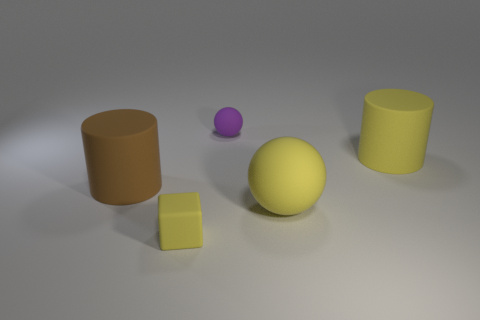Add 4 tiny matte balls. How many objects exist? 9 Subtract all balls. How many objects are left? 3 Subtract all purple spheres. Subtract all tiny brown rubber spheres. How many objects are left? 4 Add 3 balls. How many balls are left? 5 Add 3 tiny purple spheres. How many tiny purple spheres exist? 4 Subtract 0 red cubes. How many objects are left? 5 